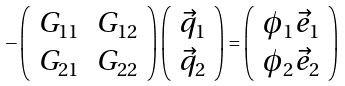Convert formula to latex. <formula><loc_0><loc_0><loc_500><loc_500>- \left ( \begin{array} { c c } G _ { 1 1 } & G _ { 1 2 } \\ G _ { 2 1 } & G _ { 2 2 } \end{array} \right ) \left ( \begin{array} { c } \vec { q } _ { 1 } \\ \vec { q } _ { 2 } \end{array} \right ) = \left ( \begin{array} { c } \phi _ { 1 } \vec { e } _ { 1 } \\ \phi _ { 2 } \vec { e } _ { 2 } \end{array} \right )</formula> 